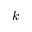Convert formula to latex. <formula><loc_0><loc_0><loc_500><loc_500>k ^ { - }</formula> 